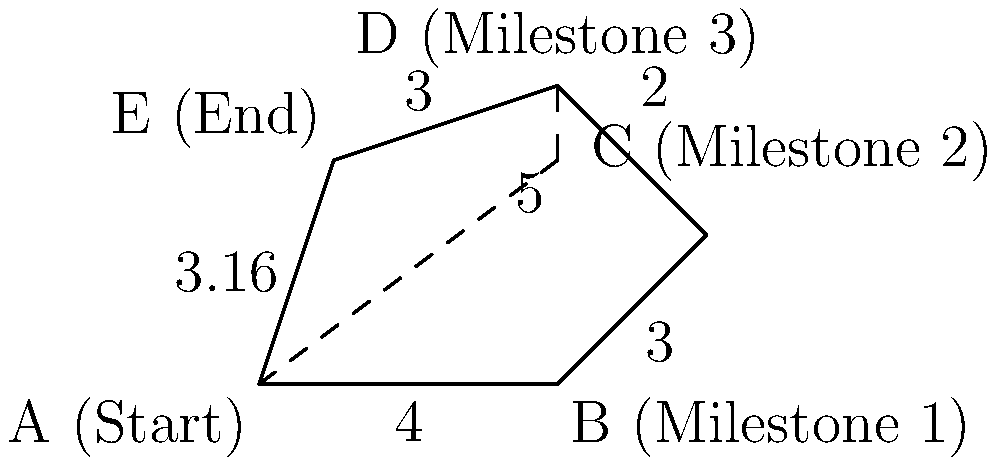In your project management diagram, each side of the irregular polygon represents a phase between project milestones. Calculate the total perimeter of the polygon to determine the overall project timeline. Round your answer to two decimal places. To calculate the perimeter of the irregular polygon, we need to sum up the lengths of all sides:

1. Side AB (Start to Milestone 1): 4 units
2. Side BC (Milestone 1 to Milestone 2): 3 units
3. Side CD (Milestone 2 to Milestone 3): 2 units
4. Side DE (Milestone 3 to End): 3 units
5. Side EA (End back to Start): This is a diagonal and needs to be calculated using the Pythagorean theorem.

For side EA:
- The horizontal distance is 1 unit
- The vertical distance is 3 units
- Using the Pythagorean theorem: $\sqrt{1^2 + 3^2} = \sqrt{1 + 9} = \sqrt{10} \approx 3.16$ units

Now, we sum up all the sides:
$4 + 3 + 2 + 3 + 3.16 = 15.16$ units

Rounding to two decimal places: 15.16 units
Answer: 15.16 units 